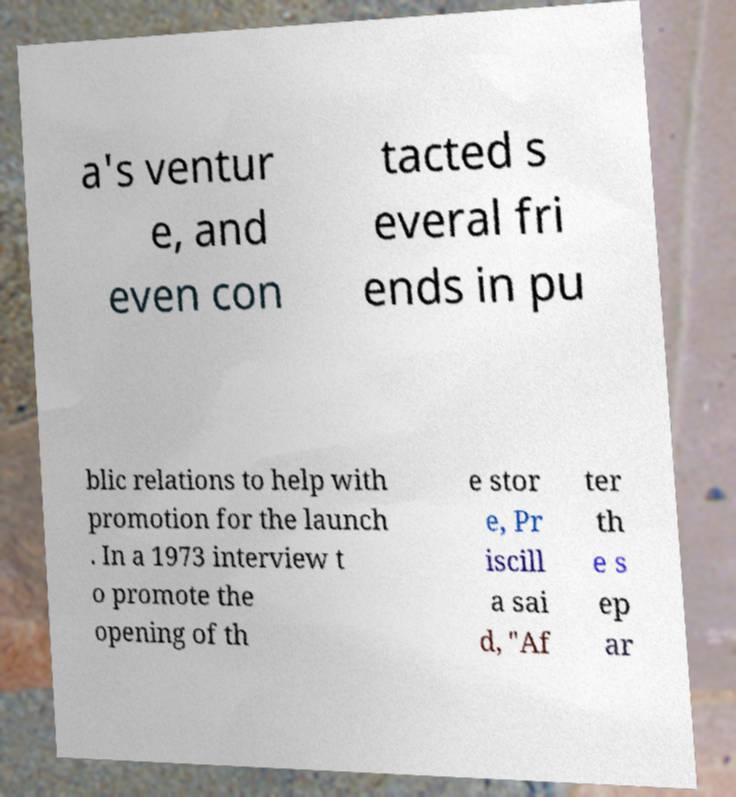Could you assist in decoding the text presented in this image and type it out clearly? a's ventur e, and even con tacted s everal fri ends in pu blic relations to help with promotion for the launch . In a 1973 interview t o promote the opening of th e stor e, Pr iscill a sai d, "Af ter th e s ep ar 